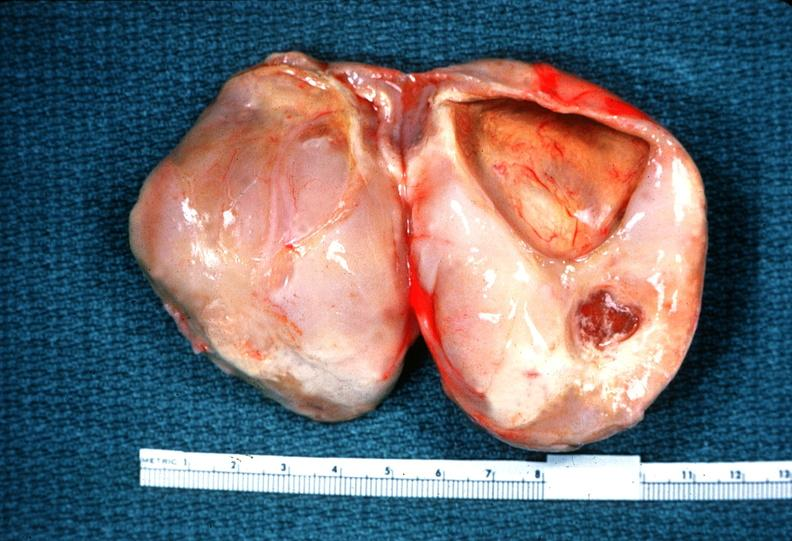what does this image show?
Answer the question using a single word or phrase. Schwannoma 